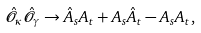<formula> <loc_0><loc_0><loc_500><loc_500>\hat { \mathcal { O } } _ { \kappa } \hat { \mathcal { O } } _ { \gamma } \to \hat { A } _ { s } A _ { t } + A _ { s } \hat { A } _ { t } - A _ { s } A _ { t } ,</formula> 